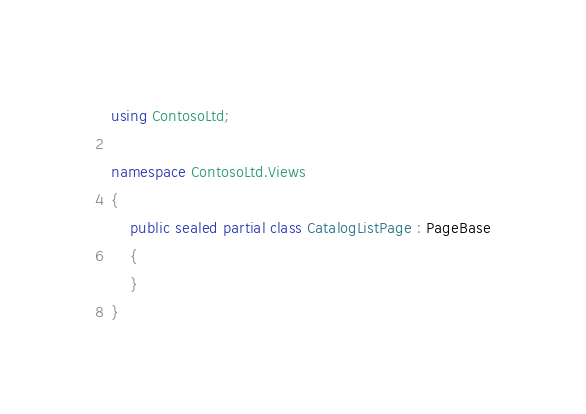<code> <loc_0><loc_0><loc_500><loc_500><_C#_>using ContosoLtd;

namespace ContosoLtd.Views
{
    public sealed partial class CatalogListPage : PageBase
    {
    }
}
</code> 